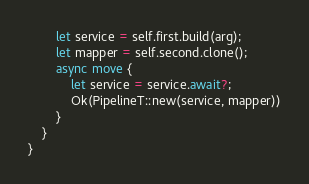Convert code to text. <code><loc_0><loc_0><loc_500><loc_500><_Rust_>        let service = self.first.build(arg);
        let mapper = self.second.clone();
        async move {
            let service = service.await?;
            Ok(PipelineT::new(service, mapper))
        }
    }
}
</code> 